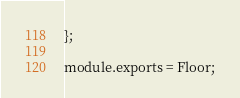Convert code to text. <code><loc_0><loc_0><loc_500><loc_500><_JavaScript_>};

module.exports = Floor;
</code> 